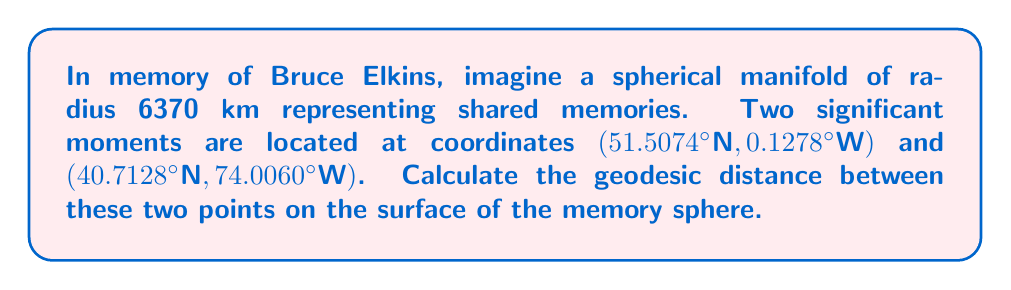Solve this math problem. To calculate the geodesic distance between two points on a spherical manifold, we'll use the Haversine formula. This formula is particularly suitable for calculating great-circle distances on a sphere.

Let's define our variables:
- $\phi_1, \lambda_1$: latitude and longitude of point 1 (London)
- $\phi_2, \lambda_2$: latitude and longitude of point 2 (New York)
- $R$: radius of the sphere (Earth in this case)

The Haversine formula is:

$$d = 2R \arcsin\left(\sqrt{\sin^2\left(\frac{\phi_2 - \phi_1}{2}\right) + \cos(\phi_1)\cos(\phi_2)\sin^2\left(\frac{\lambda_2 - \lambda_1}{2}\right)}\right)$$

Steps:
1) Convert degrees to radians:
   $\phi_1 = 51.5074° \times \frac{\pi}{180} = 0.8990$ rad
   $\lambda_1 = -0.1278° \times \frac{\pi}{180} = -0.0022$ rad
   $\phi_2 = 40.7128° \times \frac{\pi}{180} = 0.7105$ rad
   $\lambda_2 = -74.0060° \times \frac{\pi}{180} = -1.2913$ rad

2) Calculate the differences:
   $\Delta\phi = \phi_2 - \phi_1 = -0.1885$ rad
   $\Delta\lambda = \lambda_2 - \lambda_1 = -1.2891$ rad

3) Apply the Haversine formula:
   $$d = 2 \times 6370 \times \arcsin\left(\sqrt{\sin^2\left(\frac{-0.1885}{2}\right) + \cos(0.8990)\cos(0.7105)\sin^2\left(\frac{-1.2891}{2}\right)}\right)$$

4) Solve:
   $d \approx 5570.25$ km

This distance represents the shortest path between these two memory points on the spherical manifold of shared experiences with Bruce Elkins.
Answer: The geodesic distance between the two memory points on the spherical manifold is approximately 5570.25 km. 